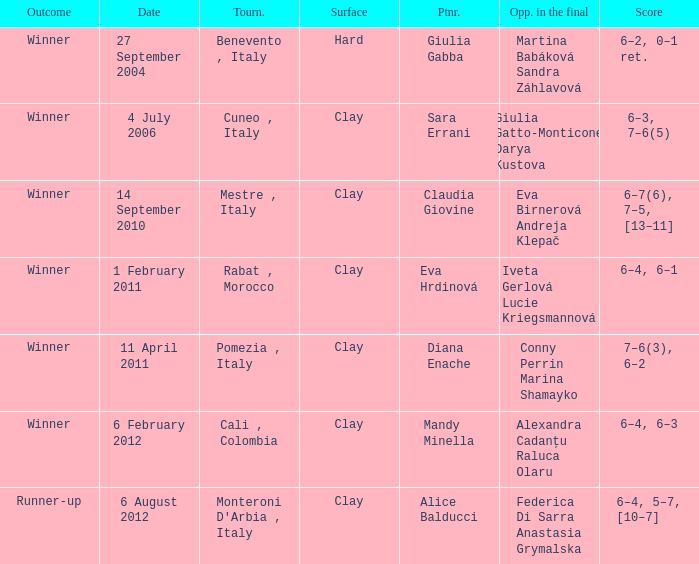Parse the table in full. {'header': ['Outcome', 'Date', 'Tourn.', 'Surface', 'Ptnr.', 'Opp. in the final', 'Score'], 'rows': [['Winner', '27 September 2004', 'Benevento , Italy', 'Hard', 'Giulia Gabba', 'Martina Babáková Sandra Záhlavová', '6–2, 0–1 ret.'], ['Winner', '4 July 2006', 'Cuneo , Italy', 'Clay', 'Sara Errani', 'Giulia Gatto-Monticone Darya Kustova', '6–3, 7–6(5)'], ['Winner', '14 September 2010', 'Mestre , Italy', 'Clay', 'Claudia Giovine', 'Eva Birnerová Andreja Klepač', '6–7(6), 7–5, [13–11]'], ['Winner', '1 February 2011', 'Rabat , Morocco', 'Clay', 'Eva Hrdinová', 'Iveta Gerlová Lucie Kriegsmannová', '6–4, 6–1'], ['Winner', '11 April 2011', 'Pomezia , Italy', 'Clay', 'Diana Enache', 'Conny Perrin Marina Shamayko', '7–6(3), 6–2'], ['Winner', '6 February 2012', 'Cali , Colombia', 'Clay', 'Mandy Minella', 'Alexandra Cadanțu Raluca Olaru', '6–4, 6–3'], ['Runner-up', '6 August 2012', "Monteroni D'Arbia , Italy", 'Clay', 'Alice Balducci', 'Federica Di Sarra Anastasia Grymalska', '6–4, 5–7, [10–7]']]} Who played on a hard surface? Giulia Gabba. 